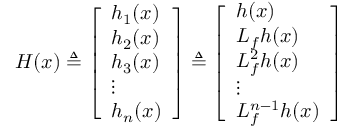Convert formula to latex. <formula><loc_0><loc_0><loc_500><loc_500>H ( x ) \triangle q { \left [ \begin{array} { l } { h _ { 1 } ( x ) } \\ { h _ { 2 } ( x ) } \\ { h _ { 3 } ( x ) } \\ { \vdots } \\ { h _ { n } ( x ) } \end{array} \right ] } \triangle q { \left [ \begin{array} { l } { h ( x ) } \\ { L _ { f } h ( x ) } \\ { L _ { f } ^ { 2 } h ( x ) } \\ { \vdots } \\ { L _ { f } ^ { n - 1 } h ( x ) } \end{array} \right ] }</formula> 